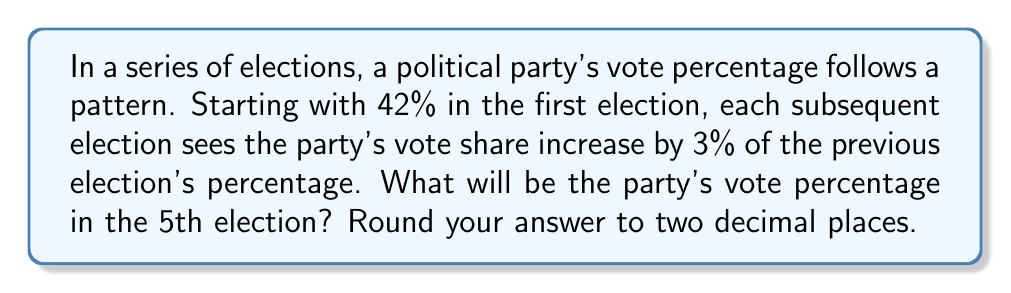Provide a solution to this math problem. Let's approach this step-by-step:

1) We start with 42% in the first election.

2) For each subsequent election, we increase by 3% of the previous percentage.
   This means we multiply the previous percentage by 1.03.

3) Let's calculate for each election:

   1st election: 42%
   2nd election: $42 \times 1.03 = 43.26\%$
   3rd election: $43.26 \times 1.03 = 44.5578\%$
   4th election: $44.5578 \times 1.03 = 45.894534\%$
   5th election: $45.894534 \times 1.03 = 47.27136802\%$

4) Rounding to two decimal places, we get 47.27%

We can express this mathematically as:

$$42 \times (1.03)^4 = 47.27136802\%$$

Where 4 is the number of increases (from 1st to 5th election).
Answer: 47.27% 